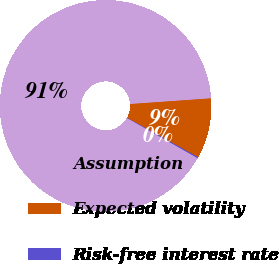<chart> <loc_0><loc_0><loc_500><loc_500><pie_chart><fcel>Assumption<fcel>Expected volatility<fcel>Risk-free interest rate<nl><fcel>90.64%<fcel>9.2%<fcel>0.15%<nl></chart> 